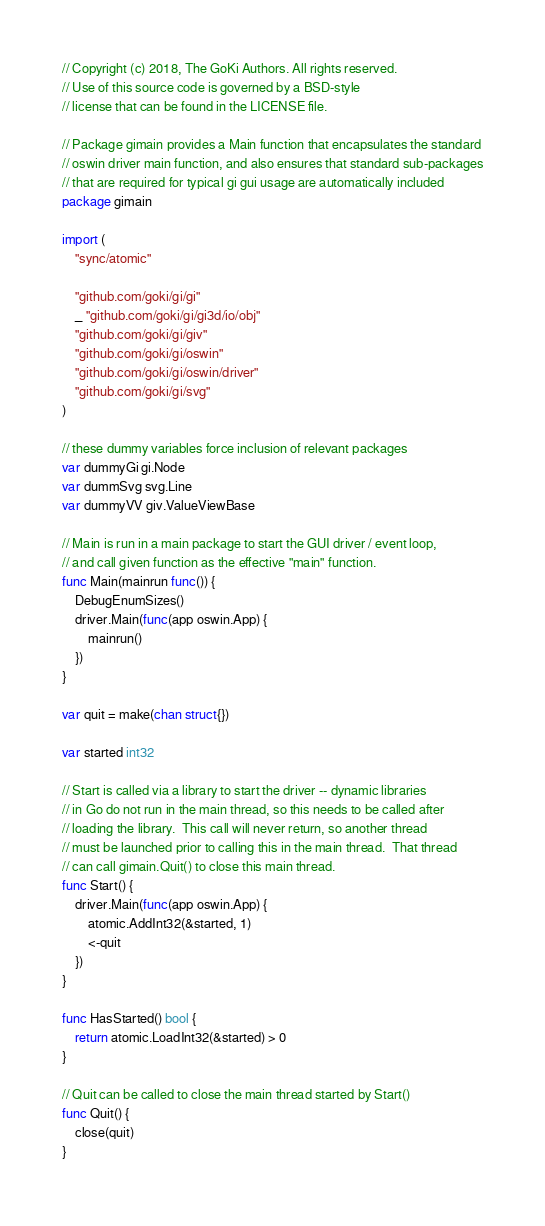Convert code to text. <code><loc_0><loc_0><loc_500><loc_500><_Go_>// Copyright (c) 2018, The GoKi Authors. All rights reserved.
// Use of this source code is governed by a BSD-style
// license that can be found in the LICENSE file.

// Package gimain provides a Main function that encapsulates the standard
// oswin driver main function, and also ensures that standard sub-packages
// that are required for typical gi gui usage are automatically included
package gimain

import (
	"sync/atomic"

	"github.com/goki/gi/gi"
	_ "github.com/goki/gi/gi3d/io/obj"
	"github.com/goki/gi/giv"
	"github.com/goki/gi/oswin"
	"github.com/goki/gi/oswin/driver"
	"github.com/goki/gi/svg"
)

// these dummy variables force inclusion of relevant packages
var dummyGi gi.Node
var dummSvg svg.Line
var dummyVV giv.ValueViewBase

// Main is run in a main package to start the GUI driver / event loop,
// and call given function as the effective "main" function.
func Main(mainrun func()) {
	DebugEnumSizes()
	driver.Main(func(app oswin.App) {
		mainrun()
	})
}

var quit = make(chan struct{})

var started int32

// Start is called via a library to start the driver -- dynamic libraries
// in Go do not run in the main thread, so this needs to be called after
// loading the library.  This call will never return, so another thread
// must be launched prior to calling this in the main thread.  That thread
// can call gimain.Quit() to close this main thread.
func Start() {
	driver.Main(func(app oswin.App) {
		atomic.AddInt32(&started, 1)
		<-quit
	})
}

func HasStarted() bool {
	return atomic.LoadInt32(&started) > 0
}

// Quit can be called to close the main thread started by Start()
func Quit() {
	close(quit)
}
</code> 